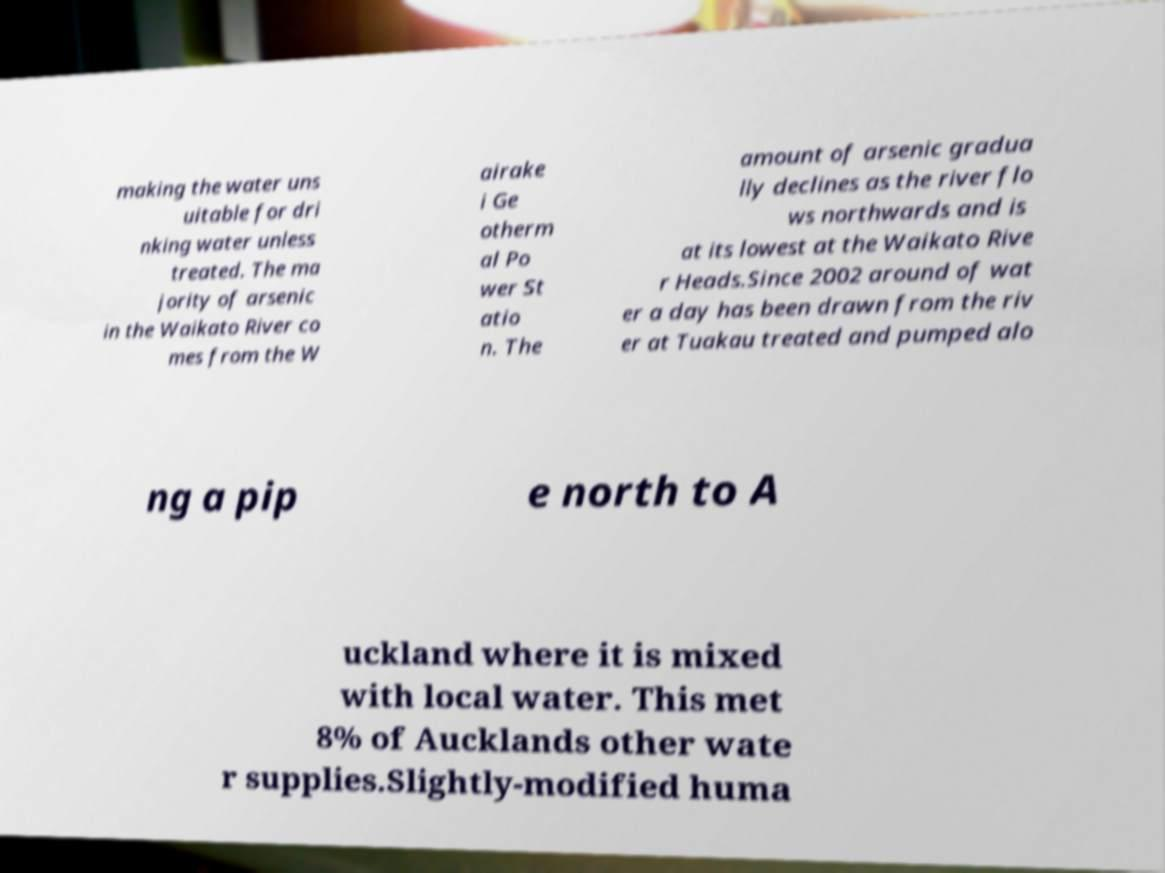Could you extract and type out the text from this image? making the water uns uitable for dri nking water unless treated. The ma jority of arsenic in the Waikato River co mes from the W airake i Ge otherm al Po wer St atio n. The amount of arsenic gradua lly declines as the river flo ws northwards and is at its lowest at the Waikato Rive r Heads.Since 2002 around of wat er a day has been drawn from the riv er at Tuakau treated and pumped alo ng a pip e north to A uckland where it is mixed with local water. This met 8% of Aucklands other wate r supplies.Slightly-modified huma 